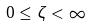<formula> <loc_0><loc_0><loc_500><loc_500>0 \leq \zeta < \infty</formula> 